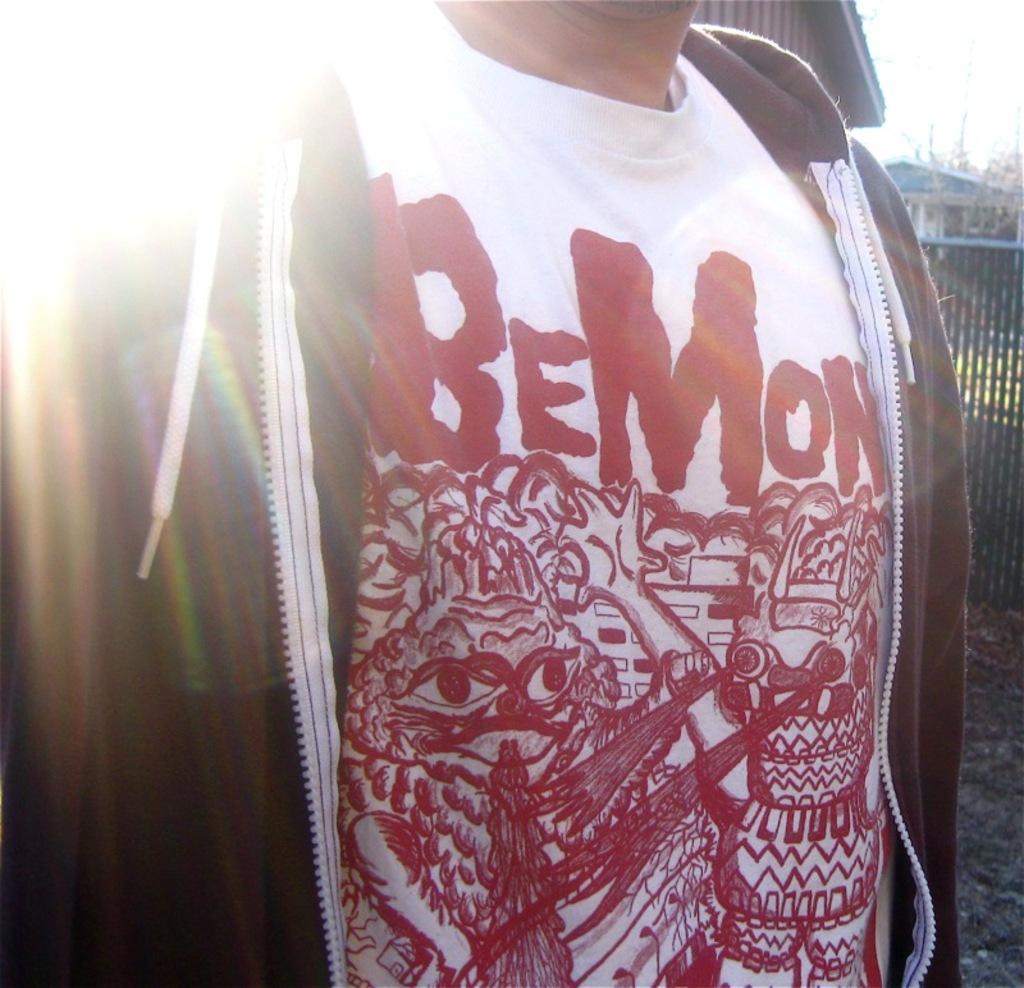In one or two sentences, can you explain what this image depicts? In this image I can see a man is standing and wearing a t-shirt and a hoodie. On the t-shirt I can see red color design and something written on it. In the background I can see the sky and other objects. 